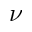<formula> <loc_0><loc_0><loc_500><loc_500>\nu</formula> 